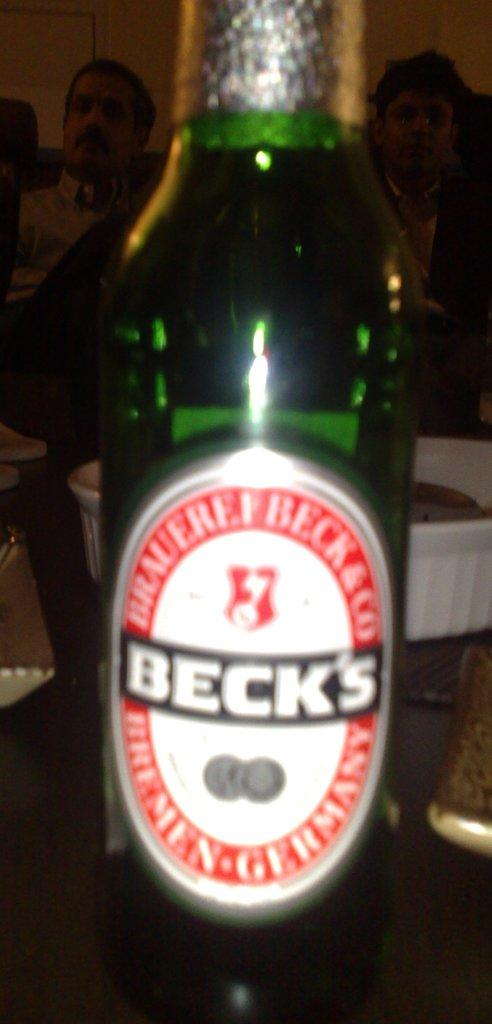What object is on the table in the image? There is a bottle on the table in the image. Can you describe the scene in the background of the image? There are people in the background of the image. What language are the people in the background speaking in the image? There is no information about the language spoken by the people in the background. 